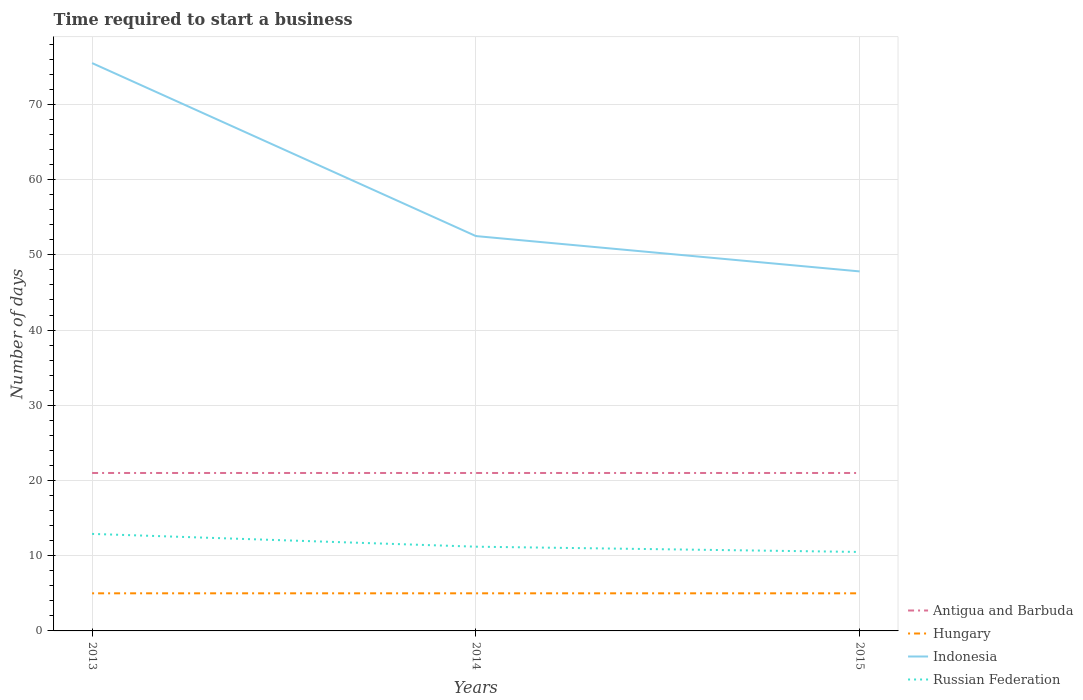In which year was the number of days required to start a business in Indonesia maximum?
Your answer should be very brief. 2015. What is the total number of days required to start a business in Hungary in the graph?
Keep it short and to the point. 0. What is the difference between the highest and the second highest number of days required to start a business in Hungary?
Your response must be concise. 0. How many years are there in the graph?
Your answer should be compact. 3. Are the values on the major ticks of Y-axis written in scientific E-notation?
Give a very brief answer. No. Does the graph contain any zero values?
Make the answer very short. No. Does the graph contain grids?
Your response must be concise. Yes. Where does the legend appear in the graph?
Your answer should be very brief. Bottom right. What is the title of the graph?
Ensure brevity in your answer.  Time required to start a business. What is the label or title of the X-axis?
Give a very brief answer. Years. What is the label or title of the Y-axis?
Make the answer very short. Number of days. What is the Number of days in Hungary in 2013?
Provide a short and direct response. 5. What is the Number of days in Indonesia in 2013?
Your response must be concise. 75.5. What is the Number of days in Russian Federation in 2013?
Make the answer very short. 12.9. What is the Number of days of Antigua and Barbuda in 2014?
Your response must be concise. 21. What is the Number of days of Hungary in 2014?
Offer a very short reply. 5. What is the Number of days of Indonesia in 2014?
Provide a short and direct response. 52.5. What is the Number of days in Antigua and Barbuda in 2015?
Your response must be concise. 21. What is the Number of days in Indonesia in 2015?
Offer a very short reply. 47.8. Across all years, what is the maximum Number of days in Antigua and Barbuda?
Give a very brief answer. 21. Across all years, what is the maximum Number of days of Hungary?
Your answer should be compact. 5. Across all years, what is the maximum Number of days of Indonesia?
Ensure brevity in your answer.  75.5. Across all years, what is the minimum Number of days in Antigua and Barbuda?
Keep it short and to the point. 21. Across all years, what is the minimum Number of days in Hungary?
Provide a succinct answer. 5. Across all years, what is the minimum Number of days in Indonesia?
Ensure brevity in your answer.  47.8. What is the total Number of days of Indonesia in the graph?
Offer a very short reply. 175.8. What is the total Number of days of Russian Federation in the graph?
Offer a terse response. 34.6. What is the difference between the Number of days of Indonesia in 2013 and that in 2014?
Ensure brevity in your answer.  23. What is the difference between the Number of days in Antigua and Barbuda in 2013 and that in 2015?
Your answer should be compact. 0. What is the difference between the Number of days in Indonesia in 2013 and that in 2015?
Provide a succinct answer. 27.7. What is the difference between the Number of days of Russian Federation in 2013 and that in 2015?
Give a very brief answer. 2.4. What is the difference between the Number of days of Hungary in 2014 and that in 2015?
Keep it short and to the point. 0. What is the difference between the Number of days of Antigua and Barbuda in 2013 and the Number of days of Hungary in 2014?
Make the answer very short. 16. What is the difference between the Number of days of Antigua and Barbuda in 2013 and the Number of days of Indonesia in 2014?
Keep it short and to the point. -31.5. What is the difference between the Number of days in Antigua and Barbuda in 2013 and the Number of days in Russian Federation in 2014?
Your answer should be compact. 9.8. What is the difference between the Number of days of Hungary in 2013 and the Number of days of Indonesia in 2014?
Your answer should be compact. -47.5. What is the difference between the Number of days of Hungary in 2013 and the Number of days of Russian Federation in 2014?
Provide a short and direct response. -6.2. What is the difference between the Number of days in Indonesia in 2013 and the Number of days in Russian Federation in 2014?
Provide a short and direct response. 64.3. What is the difference between the Number of days of Antigua and Barbuda in 2013 and the Number of days of Hungary in 2015?
Provide a short and direct response. 16. What is the difference between the Number of days of Antigua and Barbuda in 2013 and the Number of days of Indonesia in 2015?
Your response must be concise. -26.8. What is the difference between the Number of days of Antigua and Barbuda in 2013 and the Number of days of Russian Federation in 2015?
Keep it short and to the point. 10.5. What is the difference between the Number of days of Hungary in 2013 and the Number of days of Indonesia in 2015?
Ensure brevity in your answer.  -42.8. What is the difference between the Number of days in Antigua and Barbuda in 2014 and the Number of days in Indonesia in 2015?
Ensure brevity in your answer.  -26.8. What is the difference between the Number of days in Hungary in 2014 and the Number of days in Indonesia in 2015?
Your answer should be compact. -42.8. What is the difference between the Number of days of Hungary in 2014 and the Number of days of Russian Federation in 2015?
Give a very brief answer. -5.5. What is the average Number of days in Indonesia per year?
Your answer should be very brief. 58.6. What is the average Number of days of Russian Federation per year?
Provide a succinct answer. 11.53. In the year 2013, what is the difference between the Number of days of Antigua and Barbuda and Number of days of Indonesia?
Offer a very short reply. -54.5. In the year 2013, what is the difference between the Number of days of Hungary and Number of days of Indonesia?
Make the answer very short. -70.5. In the year 2013, what is the difference between the Number of days in Indonesia and Number of days in Russian Federation?
Ensure brevity in your answer.  62.6. In the year 2014, what is the difference between the Number of days in Antigua and Barbuda and Number of days in Hungary?
Your answer should be very brief. 16. In the year 2014, what is the difference between the Number of days of Antigua and Barbuda and Number of days of Indonesia?
Offer a very short reply. -31.5. In the year 2014, what is the difference between the Number of days in Hungary and Number of days in Indonesia?
Make the answer very short. -47.5. In the year 2014, what is the difference between the Number of days in Hungary and Number of days in Russian Federation?
Offer a terse response. -6.2. In the year 2014, what is the difference between the Number of days of Indonesia and Number of days of Russian Federation?
Ensure brevity in your answer.  41.3. In the year 2015, what is the difference between the Number of days of Antigua and Barbuda and Number of days of Hungary?
Provide a succinct answer. 16. In the year 2015, what is the difference between the Number of days in Antigua and Barbuda and Number of days in Indonesia?
Offer a terse response. -26.8. In the year 2015, what is the difference between the Number of days in Antigua and Barbuda and Number of days in Russian Federation?
Your response must be concise. 10.5. In the year 2015, what is the difference between the Number of days of Hungary and Number of days of Indonesia?
Offer a very short reply. -42.8. In the year 2015, what is the difference between the Number of days in Hungary and Number of days in Russian Federation?
Provide a short and direct response. -5.5. In the year 2015, what is the difference between the Number of days in Indonesia and Number of days in Russian Federation?
Offer a very short reply. 37.3. What is the ratio of the Number of days in Antigua and Barbuda in 2013 to that in 2014?
Provide a succinct answer. 1. What is the ratio of the Number of days in Indonesia in 2013 to that in 2014?
Ensure brevity in your answer.  1.44. What is the ratio of the Number of days of Russian Federation in 2013 to that in 2014?
Provide a succinct answer. 1.15. What is the ratio of the Number of days in Antigua and Barbuda in 2013 to that in 2015?
Your answer should be very brief. 1. What is the ratio of the Number of days of Hungary in 2013 to that in 2015?
Provide a succinct answer. 1. What is the ratio of the Number of days in Indonesia in 2013 to that in 2015?
Your answer should be compact. 1.58. What is the ratio of the Number of days in Russian Federation in 2013 to that in 2015?
Offer a very short reply. 1.23. What is the ratio of the Number of days in Antigua and Barbuda in 2014 to that in 2015?
Keep it short and to the point. 1. What is the ratio of the Number of days in Indonesia in 2014 to that in 2015?
Give a very brief answer. 1.1. What is the ratio of the Number of days of Russian Federation in 2014 to that in 2015?
Give a very brief answer. 1.07. What is the difference between the highest and the second highest Number of days in Antigua and Barbuda?
Make the answer very short. 0. What is the difference between the highest and the second highest Number of days in Hungary?
Offer a very short reply. 0. What is the difference between the highest and the second highest Number of days of Russian Federation?
Your answer should be compact. 1.7. What is the difference between the highest and the lowest Number of days of Hungary?
Your response must be concise. 0. What is the difference between the highest and the lowest Number of days of Indonesia?
Make the answer very short. 27.7. 